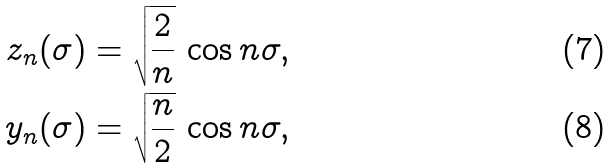<formula> <loc_0><loc_0><loc_500><loc_500>\ z _ { n } ( \sigma ) & = \sqrt { \frac { 2 } { n } } \, \cos n \sigma , \\ \ y _ { n } ( \sigma ) & = \sqrt { \frac { n } { 2 } } \, \cos n \sigma ,</formula> 